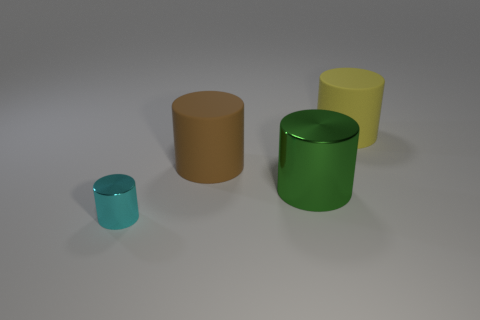Add 1 small metal objects. How many objects exist? 5 Subtract all small metallic things. Subtract all red balls. How many objects are left? 3 Add 2 cylinders. How many cylinders are left? 6 Add 3 big yellow cubes. How many big yellow cubes exist? 3 Subtract 0 purple cylinders. How many objects are left? 4 